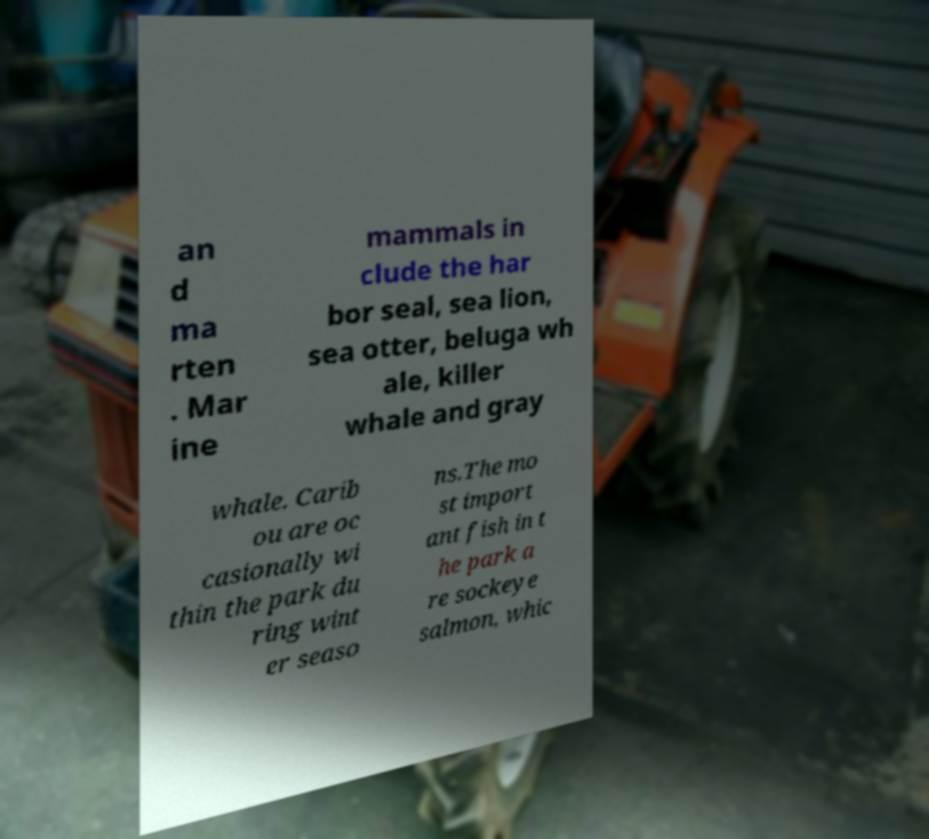What messages or text are displayed in this image? I need them in a readable, typed format. an d ma rten . Mar ine mammals in clude the har bor seal, sea lion, sea otter, beluga wh ale, killer whale and gray whale. Carib ou are oc casionally wi thin the park du ring wint er seaso ns.The mo st import ant fish in t he park a re sockeye salmon, whic 